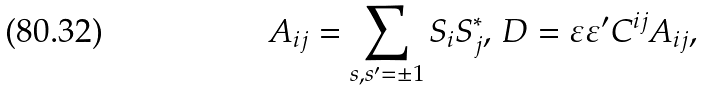Convert formula to latex. <formula><loc_0><loc_0><loc_500><loc_500>A _ { i j } = \sum _ { s , s ^ { \prime } = \pm 1 } S _ { i } S _ { j } ^ { \ast } , \, D = \varepsilon \varepsilon ^ { \prime } C ^ { i j } A _ { i j } ,</formula> 